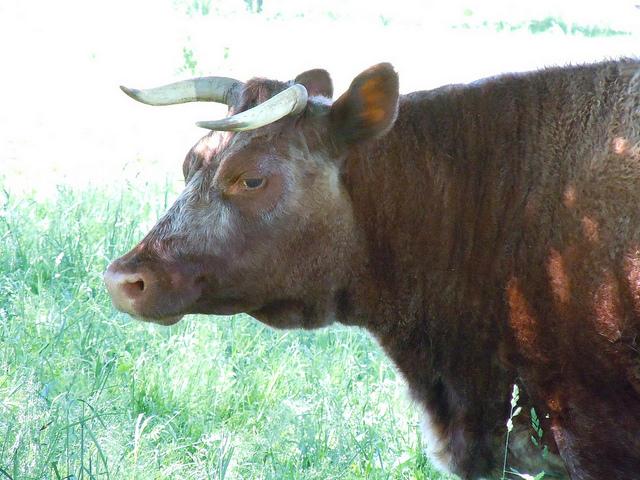Does this animal have horns?
Give a very brief answer. Yes. Does this bull look like it has been injured recently?
Concise answer only. Yes. Is this a domesticated animal?
Quick response, please. Yes. 